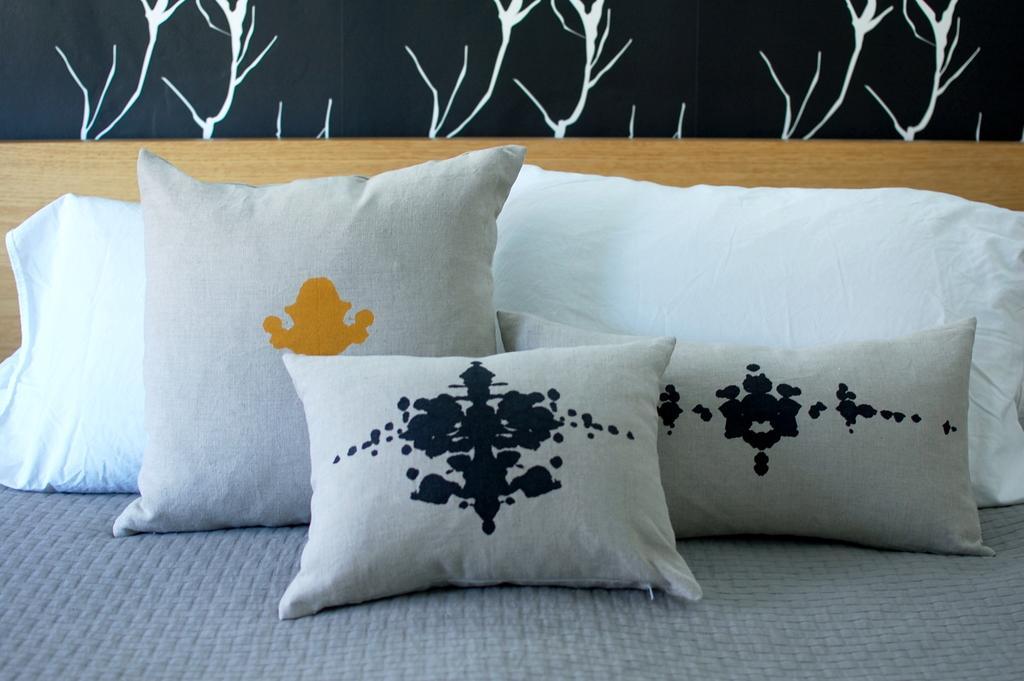Can you describe this image briefly? In this picture we can see pillows on a cloth and in the background we can see a wooden object and painting on the wall. 